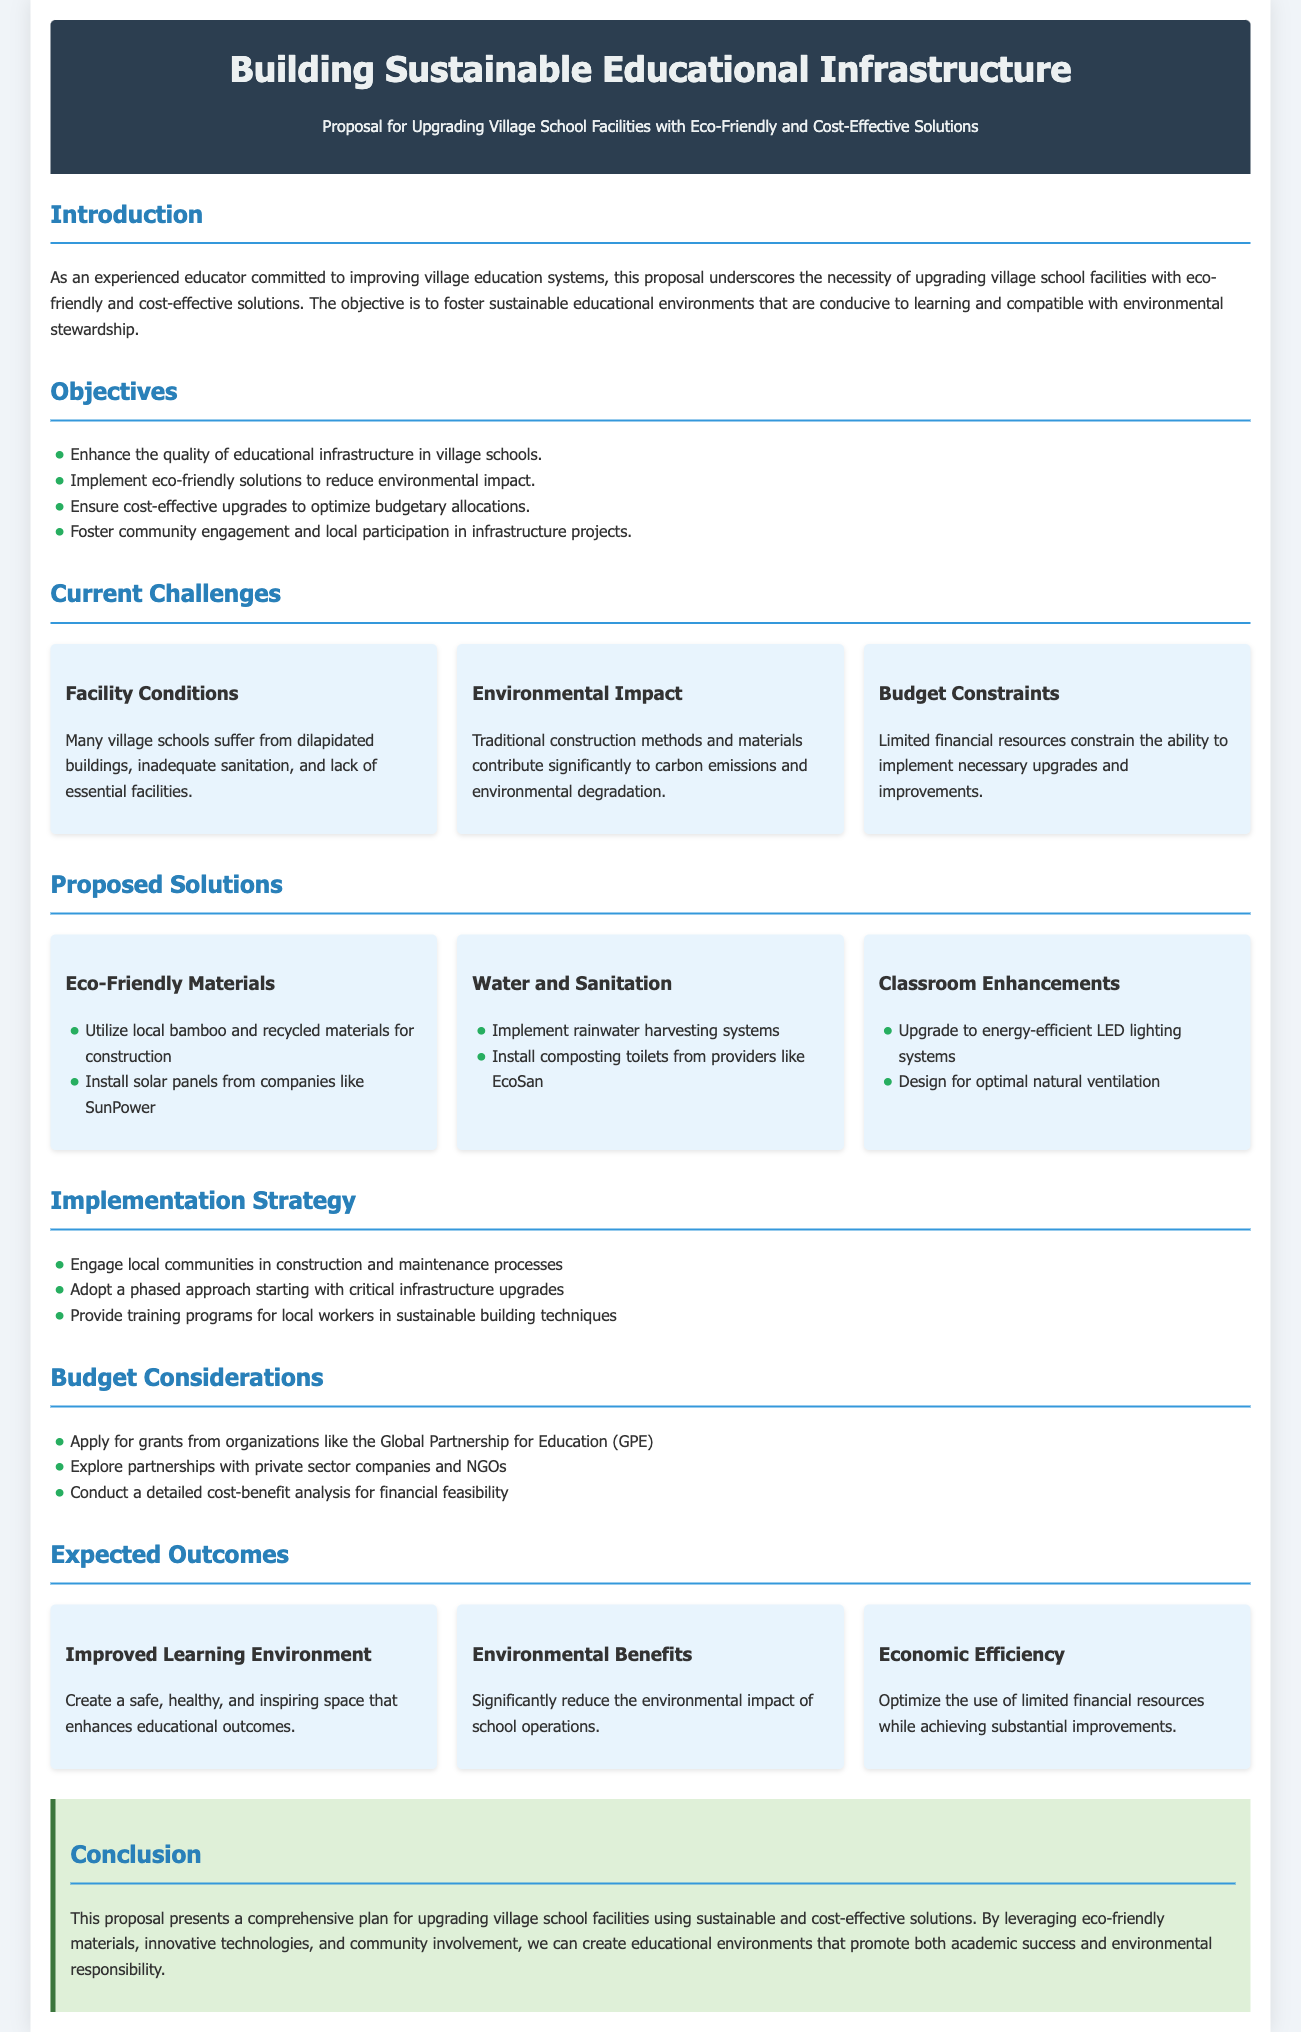What is the main objective of the proposal? The main objective is to upgrade village school facilities with eco-friendly and cost-effective solutions.
Answer: to upgrade village school facilities with eco-friendly and cost-effective solutions Which eco-friendly material is suggested for construction? The proposal suggests utilizing local bamboo and recycled materials for construction.
Answer: local bamboo and recycled materials What is one of the current challenges faced by village schools? One current challenge is the facility conditions, which include dilapidated buildings and inadequate sanitation.
Answer: facility conditions What solution is proposed for water and sanitation improvements? The proposal suggests implementing rainwater harvesting systems.
Answer: rainwater harvesting systems Which organization is mentioned for potential grant applications? The organization mentioned is the Global Partnership for Education (GPE).
Answer: Global Partnership for Education (GPE) What type of lighting upgrade is proposed for classrooms? The proposal suggests upgrading to energy-efficient LED lighting systems.
Answer: energy-efficient LED lighting systems How will local communities participate in the implementation strategy? Local communities will engage in construction and maintenance processes.
Answer: construction and maintenance processes What is the expected outcome related to economic efficiency? The expected outcome is optimizing the use of limited financial resources while achieving substantial improvements.
Answer: optimizing the use of limited financial resources What type of toilets is proposed for installation? The proposal suggests installing composting toilets from providers like EcoSan.
Answer: composting toilets What is the concluding statement's focus in the proposal? The conclusion emphasizes creating educational environments that promote academic success and environmental responsibility.
Answer: academic success and environmental responsibility 